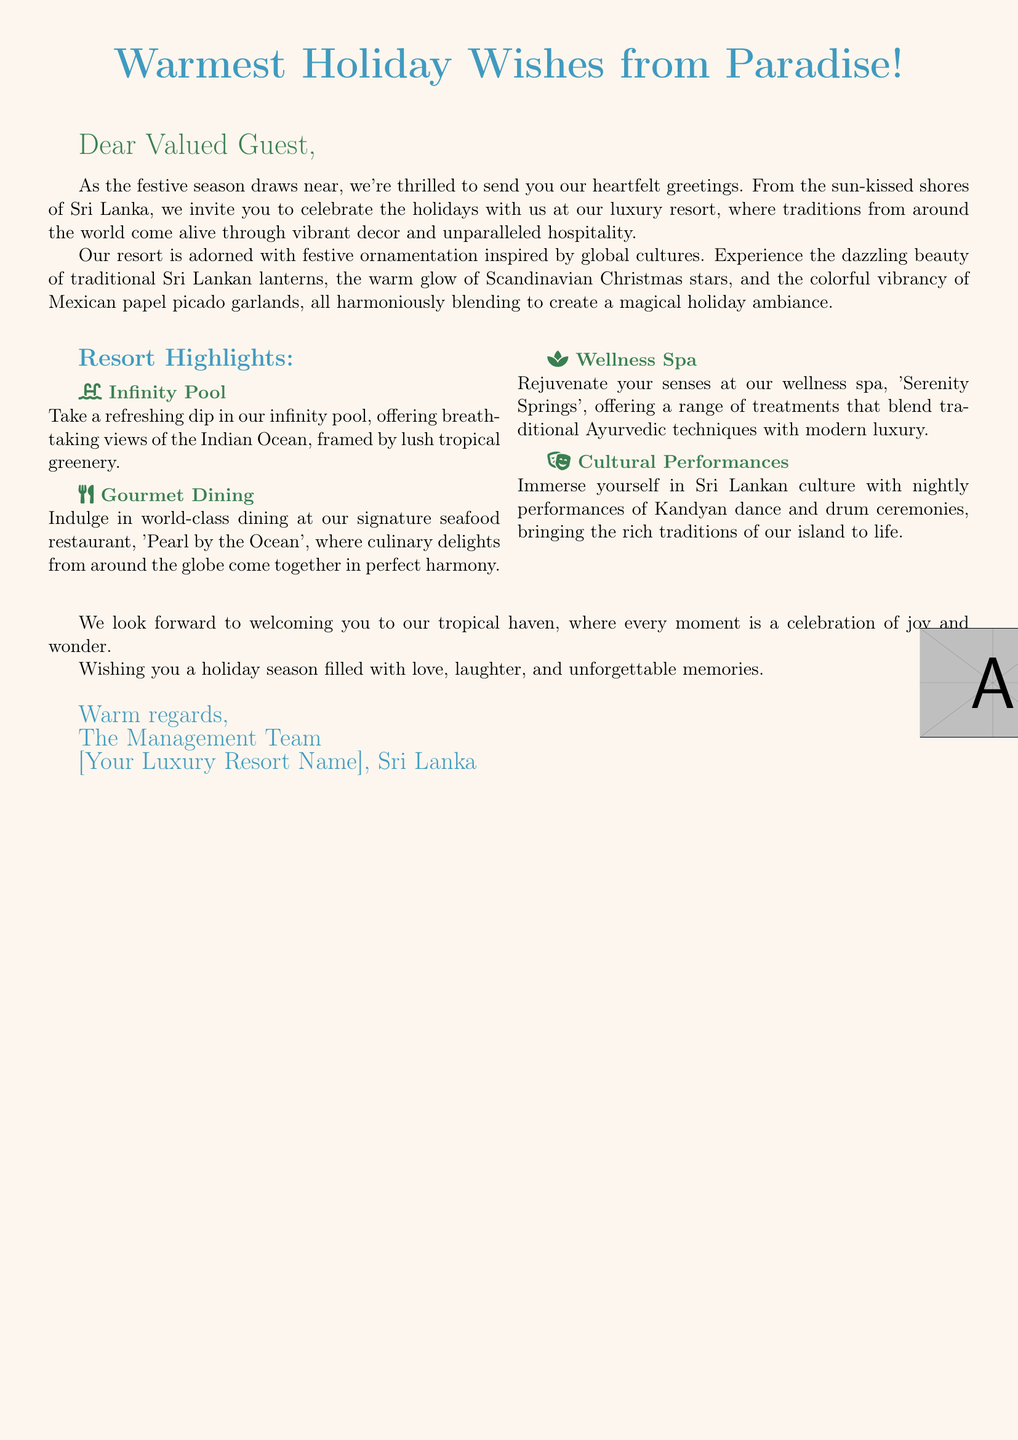What is the name of the signature seafood restaurant? The document mentions the signature seafood restaurant is called 'Pearl by the Ocean'.
Answer: 'Pearl by the Ocean' What type of pool does the resort feature? The document describes the pool as an infinity pool, which offers breathtaking views.
Answer: Infinity Pool What cultural performances are highlighted in the document? The document states that nightly performances of Kandyan dance and drum ceremonies are showcased.
Answer: Kandyan dance and drum ceremonies Which spa offers treatments at the resort? The wellness spa mentioned in the document is named 'Serenity Springs'.
Answer: Serenity Springs What decorative items are used to celebrate the holidays? The document lists traditional Sri Lankan lanterns, Scandinavian Christmas stars, and Mexican papel picado garlands as part of the festive decor.
Answer: Traditional Sri Lankan lanterns, Scandinavian Christmas stars, and Mexican papel picado garlands How are the greetings addressed in the card? The greetings in the card are addressed to "Dear Valued Guest."
Answer: Dear Valued Guest What is the primary message of the holiday card? The card conveys warm holiday wishes and an invitation to celebrate the holidays at the resort.
Answer: Warmest Holiday Wishes from Paradise How does the document convey its global holiday theme? The document describes a blend of festive decor from various cultures, showcasing traditions around the world.
Answer: Blending festive decor from various cultures 